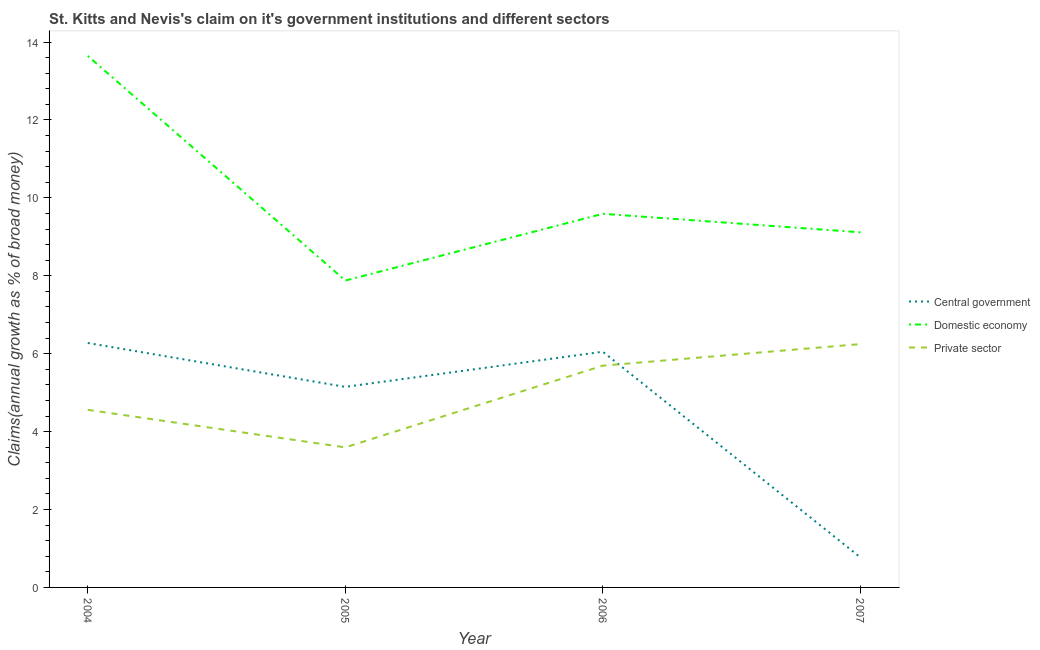How many different coloured lines are there?
Offer a terse response. 3. What is the percentage of claim on the central government in 2004?
Make the answer very short. 6.28. Across all years, what is the maximum percentage of claim on the central government?
Provide a short and direct response. 6.28. Across all years, what is the minimum percentage of claim on the central government?
Give a very brief answer. 0.77. In which year was the percentage of claim on the central government minimum?
Ensure brevity in your answer.  2007. What is the total percentage of claim on the central government in the graph?
Make the answer very short. 18.25. What is the difference between the percentage of claim on the domestic economy in 2005 and that in 2006?
Provide a succinct answer. -1.71. What is the difference between the percentage of claim on the private sector in 2004 and the percentage of claim on the domestic economy in 2005?
Give a very brief answer. -3.32. What is the average percentage of claim on the central government per year?
Your response must be concise. 4.56. In the year 2004, what is the difference between the percentage of claim on the private sector and percentage of claim on the central government?
Your answer should be very brief. -1.72. What is the ratio of the percentage of claim on the central government in 2005 to that in 2007?
Your response must be concise. 6.68. Is the difference between the percentage of claim on the domestic economy in 2004 and 2007 greater than the difference between the percentage of claim on the private sector in 2004 and 2007?
Provide a succinct answer. Yes. What is the difference between the highest and the second highest percentage of claim on the central government?
Your answer should be compact. 0.22. What is the difference between the highest and the lowest percentage of claim on the domestic economy?
Keep it short and to the point. 5.77. In how many years, is the percentage of claim on the central government greater than the average percentage of claim on the central government taken over all years?
Ensure brevity in your answer.  3. Is the percentage of claim on the domestic economy strictly greater than the percentage of claim on the central government over the years?
Give a very brief answer. Yes. How many lines are there?
Provide a succinct answer. 3. What is the difference between two consecutive major ticks on the Y-axis?
Keep it short and to the point. 2. Are the values on the major ticks of Y-axis written in scientific E-notation?
Make the answer very short. No. Does the graph contain grids?
Give a very brief answer. No. How are the legend labels stacked?
Provide a succinct answer. Vertical. What is the title of the graph?
Give a very brief answer. St. Kitts and Nevis's claim on it's government institutions and different sectors. What is the label or title of the X-axis?
Ensure brevity in your answer.  Year. What is the label or title of the Y-axis?
Offer a terse response. Claims(annual growth as % of broad money). What is the Claims(annual growth as % of broad money) in Central government in 2004?
Make the answer very short. 6.28. What is the Claims(annual growth as % of broad money) of Domestic economy in 2004?
Offer a terse response. 13.65. What is the Claims(annual growth as % of broad money) in Private sector in 2004?
Provide a succinct answer. 4.56. What is the Claims(annual growth as % of broad money) in Central government in 2005?
Your answer should be compact. 5.15. What is the Claims(annual growth as % of broad money) of Domestic economy in 2005?
Provide a short and direct response. 7.88. What is the Claims(annual growth as % of broad money) of Private sector in 2005?
Your response must be concise. 3.6. What is the Claims(annual growth as % of broad money) in Central government in 2006?
Provide a short and direct response. 6.05. What is the Claims(annual growth as % of broad money) of Domestic economy in 2006?
Ensure brevity in your answer.  9.59. What is the Claims(annual growth as % of broad money) in Private sector in 2006?
Give a very brief answer. 5.69. What is the Claims(annual growth as % of broad money) in Central government in 2007?
Provide a short and direct response. 0.77. What is the Claims(annual growth as % of broad money) in Domestic economy in 2007?
Your answer should be compact. 9.12. What is the Claims(annual growth as % of broad money) in Private sector in 2007?
Ensure brevity in your answer.  6.25. Across all years, what is the maximum Claims(annual growth as % of broad money) of Central government?
Give a very brief answer. 6.28. Across all years, what is the maximum Claims(annual growth as % of broad money) of Domestic economy?
Your answer should be very brief. 13.65. Across all years, what is the maximum Claims(annual growth as % of broad money) of Private sector?
Give a very brief answer. 6.25. Across all years, what is the minimum Claims(annual growth as % of broad money) in Central government?
Your response must be concise. 0.77. Across all years, what is the minimum Claims(annual growth as % of broad money) in Domestic economy?
Provide a short and direct response. 7.88. Across all years, what is the minimum Claims(annual growth as % of broad money) in Private sector?
Your response must be concise. 3.6. What is the total Claims(annual growth as % of broad money) in Central government in the graph?
Keep it short and to the point. 18.25. What is the total Claims(annual growth as % of broad money) of Domestic economy in the graph?
Give a very brief answer. 40.23. What is the total Claims(annual growth as % of broad money) of Private sector in the graph?
Your response must be concise. 20.1. What is the difference between the Claims(annual growth as % of broad money) of Central government in 2004 and that in 2005?
Keep it short and to the point. 1.13. What is the difference between the Claims(annual growth as % of broad money) of Domestic economy in 2004 and that in 2005?
Offer a terse response. 5.77. What is the difference between the Claims(annual growth as % of broad money) of Private sector in 2004 and that in 2005?
Provide a short and direct response. 0.96. What is the difference between the Claims(annual growth as % of broad money) of Central government in 2004 and that in 2006?
Keep it short and to the point. 0.22. What is the difference between the Claims(annual growth as % of broad money) of Domestic economy in 2004 and that in 2006?
Offer a terse response. 4.05. What is the difference between the Claims(annual growth as % of broad money) of Private sector in 2004 and that in 2006?
Your answer should be compact. -1.13. What is the difference between the Claims(annual growth as % of broad money) in Central government in 2004 and that in 2007?
Ensure brevity in your answer.  5.5. What is the difference between the Claims(annual growth as % of broad money) of Domestic economy in 2004 and that in 2007?
Provide a short and direct response. 4.53. What is the difference between the Claims(annual growth as % of broad money) in Private sector in 2004 and that in 2007?
Provide a succinct answer. -1.69. What is the difference between the Claims(annual growth as % of broad money) in Central government in 2005 and that in 2006?
Keep it short and to the point. -0.9. What is the difference between the Claims(annual growth as % of broad money) of Domestic economy in 2005 and that in 2006?
Offer a very short reply. -1.71. What is the difference between the Claims(annual growth as % of broad money) of Private sector in 2005 and that in 2006?
Offer a terse response. -2.1. What is the difference between the Claims(annual growth as % of broad money) in Central government in 2005 and that in 2007?
Offer a terse response. 4.38. What is the difference between the Claims(annual growth as % of broad money) in Domestic economy in 2005 and that in 2007?
Provide a succinct answer. -1.24. What is the difference between the Claims(annual growth as % of broad money) of Private sector in 2005 and that in 2007?
Your answer should be compact. -2.65. What is the difference between the Claims(annual growth as % of broad money) in Central government in 2006 and that in 2007?
Offer a terse response. 5.28. What is the difference between the Claims(annual growth as % of broad money) of Domestic economy in 2006 and that in 2007?
Provide a succinct answer. 0.47. What is the difference between the Claims(annual growth as % of broad money) in Private sector in 2006 and that in 2007?
Provide a short and direct response. -0.55. What is the difference between the Claims(annual growth as % of broad money) in Central government in 2004 and the Claims(annual growth as % of broad money) in Domestic economy in 2005?
Give a very brief answer. -1.6. What is the difference between the Claims(annual growth as % of broad money) in Central government in 2004 and the Claims(annual growth as % of broad money) in Private sector in 2005?
Ensure brevity in your answer.  2.68. What is the difference between the Claims(annual growth as % of broad money) of Domestic economy in 2004 and the Claims(annual growth as % of broad money) of Private sector in 2005?
Offer a very short reply. 10.05. What is the difference between the Claims(annual growth as % of broad money) in Central government in 2004 and the Claims(annual growth as % of broad money) in Domestic economy in 2006?
Provide a succinct answer. -3.32. What is the difference between the Claims(annual growth as % of broad money) of Central government in 2004 and the Claims(annual growth as % of broad money) of Private sector in 2006?
Offer a terse response. 0.58. What is the difference between the Claims(annual growth as % of broad money) of Domestic economy in 2004 and the Claims(annual growth as % of broad money) of Private sector in 2006?
Your answer should be compact. 7.95. What is the difference between the Claims(annual growth as % of broad money) in Central government in 2004 and the Claims(annual growth as % of broad money) in Domestic economy in 2007?
Your answer should be compact. -2.84. What is the difference between the Claims(annual growth as % of broad money) in Central government in 2004 and the Claims(annual growth as % of broad money) in Private sector in 2007?
Your answer should be compact. 0.03. What is the difference between the Claims(annual growth as % of broad money) in Domestic economy in 2004 and the Claims(annual growth as % of broad money) in Private sector in 2007?
Provide a succinct answer. 7.4. What is the difference between the Claims(annual growth as % of broad money) of Central government in 2005 and the Claims(annual growth as % of broad money) of Domestic economy in 2006?
Provide a succinct answer. -4.44. What is the difference between the Claims(annual growth as % of broad money) of Central government in 2005 and the Claims(annual growth as % of broad money) of Private sector in 2006?
Your answer should be compact. -0.55. What is the difference between the Claims(annual growth as % of broad money) of Domestic economy in 2005 and the Claims(annual growth as % of broad money) of Private sector in 2006?
Provide a short and direct response. 2.18. What is the difference between the Claims(annual growth as % of broad money) of Central government in 2005 and the Claims(annual growth as % of broad money) of Domestic economy in 2007?
Provide a short and direct response. -3.97. What is the difference between the Claims(annual growth as % of broad money) of Central government in 2005 and the Claims(annual growth as % of broad money) of Private sector in 2007?
Make the answer very short. -1.1. What is the difference between the Claims(annual growth as % of broad money) of Domestic economy in 2005 and the Claims(annual growth as % of broad money) of Private sector in 2007?
Ensure brevity in your answer.  1.63. What is the difference between the Claims(annual growth as % of broad money) in Central government in 2006 and the Claims(annual growth as % of broad money) in Domestic economy in 2007?
Your response must be concise. -3.07. What is the difference between the Claims(annual growth as % of broad money) of Central government in 2006 and the Claims(annual growth as % of broad money) of Private sector in 2007?
Your answer should be very brief. -0.2. What is the difference between the Claims(annual growth as % of broad money) in Domestic economy in 2006 and the Claims(annual growth as % of broad money) in Private sector in 2007?
Provide a succinct answer. 3.34. What is the average Claims(annual growth as % of broad money) in Central government per year?
Give a very brief answer. 4.56. What is the average Claims(annual growth as % of broad money) in Domestic economy per year?
Make the answer very short. 10.06. What is the average Claims(annual growth as % of broad money) of Private sector per year?
Provide a short and direct response. 5.02. In the year 2004, what is the difference between the Claims(annual growth as % of broad money) of Central government and Claims(annual growth as % of broad money) of Domestic economy?
Offer a terse response. -7.37. In the year 2004, what is the difference between the Claims(annual growth as % of broad money) in Central government and Claims(annual growth as % of broad money) in Private sector?
Your answer should be compact. 1.72. In the year 2004, what is the difference between the Claims(annual growth as % of broad money) of Domestic economy and Claims(annual growth as % of broad money) of Private sector?
Your response must be concise. 9.09. In the year 2005, what is the difference between the Claims(annual growth as % of broad money) in Central government and Claims(annual growth as % of broad money) in Domestic economy?
Your answer should be very brief. -2.73. In the year 2005, what is the difference between the Claims(annual growth as % of broad money) in Central government and Claims(annual growth as % of broad money) in Private sector?
Provide a succinct answer. 1.55. In the year 2005, what is the difference between the Claims(annual growth as % of broad money) of Domestic economy and Claims(annual growth as % of broad money) of Private sector?
Offer a terse response. 4.28. In the year 2006, what is the difference between the Claims(annual growth as % of broad money) of Central government and Claims(annual growth as % of broad money) of Domestic economy?
Provide a succinct answer. -3.54. In the year 2006, what is the difference between the Claims(annual growth as % of broad money) of Central government and Claims(annual growth as % of broad money) of Private sector?
Offer a terse response. 0.36. In the year 2006, what is the difference between the Claims(annual growth as % of broad money) of Domestic economy and Claims(annual growth as % of broad money) of Private sector?
Your response must be concise. 3.9. In the year 2007, what is the difference between the Claims(annual growth as % of broad money) in Central government and Claims(annual growth as % of broad money) in Domestic economy?
Make the answer very short. -8.35. In the year 2007, what is the difference between the Claims(annual growth as % of broad money) of Central government and Claims(annual growth as % of broad money) of Private sector?
Provide a succinct answer. -5.48. In the year 2007, what is the difference between the Claims(annual growth as % of broad money) in Domestic economy and Claims(annual growth as % of broad money) in Private sector?
Your answer should be compact. 2.87. What is the ratio of the Claims(annual growth as % of broad money) in Central government in 2004 to that in 2005?
Provide a succinct answer. 1.22. What is the ratio of the Claims(annual growth as % of broad money) in Domestic economy in 2004 to that in 2005?
Your answer should be very brief. 1.73. What is the ratio of the Claims(annual growth as % of broad money) of Private sector in 2004 to that in 2005?
Provide a succinct answer. 1.27. What is the ratio of the Claims(annual growth as % of broad money) of Central government in 2004 to that in 2006?
Keep it short and to the point. 1.04. What is the ratio of the Claims(annual growth as % of broad money) in Domestic economy in 2004 to that in 2006?
Offer a terse response. 1.42. What is the ratio of the Claims(annual growth as % of broad money) in Private sector in 2004 to that in 2006?
Provide a succinct answer. 0.8. What is the ratio of the Claims(annual growth as % of broad money) in Central government in 2004 to that in 2007?
Provide a succinct answer. 8.14. What is the ratio of the Claims(annual growth as % of broad money) of Domestic economy in 2004 to that in 2007?
Provide a succinct answer. 1.5. What is the ratio of the Claims(annual growth as % of broad money) of Private sector in 2004 to that in 2007?
Make the answer very short. 0.73. What is the ratio of the Claims(annual growth as % of broad money) of Central government in 2005 to that in 2006?
Offer a terse response. 0.85. What is the ratio of the Claims(annual growth as % of broad money) of Domestic economy in 2005 to that in 2006?
Make the answer very short. 0.82. What is the ratio of the Claims(annual growth as % of broad money) of Private sector in 2005 to that in 2006?
Give a very brief answer. 0.63. What is the ratio of the Claims(annual growth as % of broad money) of Central government in 2005 to that in 2007?
Offer a very short reply. 6.68. What is the ratio of the Claims(annual growth as % of broad money) of Domestic economy in 2005 to that in 2007?
Your response must be concise. 0.86. What is the ratio of the Claims(annual growth as % of broad money) in Private sector in 2005 to that in 2007?
Your answer should be compact. 0.58. What is the ratio of the Claims(annual growth as % of broad money) of Central government in 2006 to that in 2007?
Your answer should be very brief. 7.85. What is the ratio of the Claims(annual growth as % of broad money) in Domestic economy in 2006 to that in 2007?
Provide a succinct answer. 1.05. What is the ratio of the Claims(annual growth as % of broad money) in Private sector in 2006 to that in 2007?
Your answer should be very brief. 0.91. What is the difference between the highest and the second highest Claims(annual growth as % of broad money) of Central government?
Provide a short and direct response. 0.22. What is the difference between the highest and the second highest Claims(annual growth as % of broad money) of Domestic economy?
Your response must be concise. 4.05. What is the difference between the highest and the second highest Claims(annual growth as % of broad money) of Private sector?
Your response must be concise. 0.55. What is the difference between the highest and the lowest Claims(annual growth as % of broad money) in Central government?
Ensure brevity in your answer.  5.5. What is the difference between the highest and the lowest Claims(annual growth as % of broad money) in Domestic economy?
Offer a terse response. 5.77. What is the difference between the highest and the lowest Claims(annual growth as % of broad money) in Private sector?
Provide a succinct answer. 2.65. 